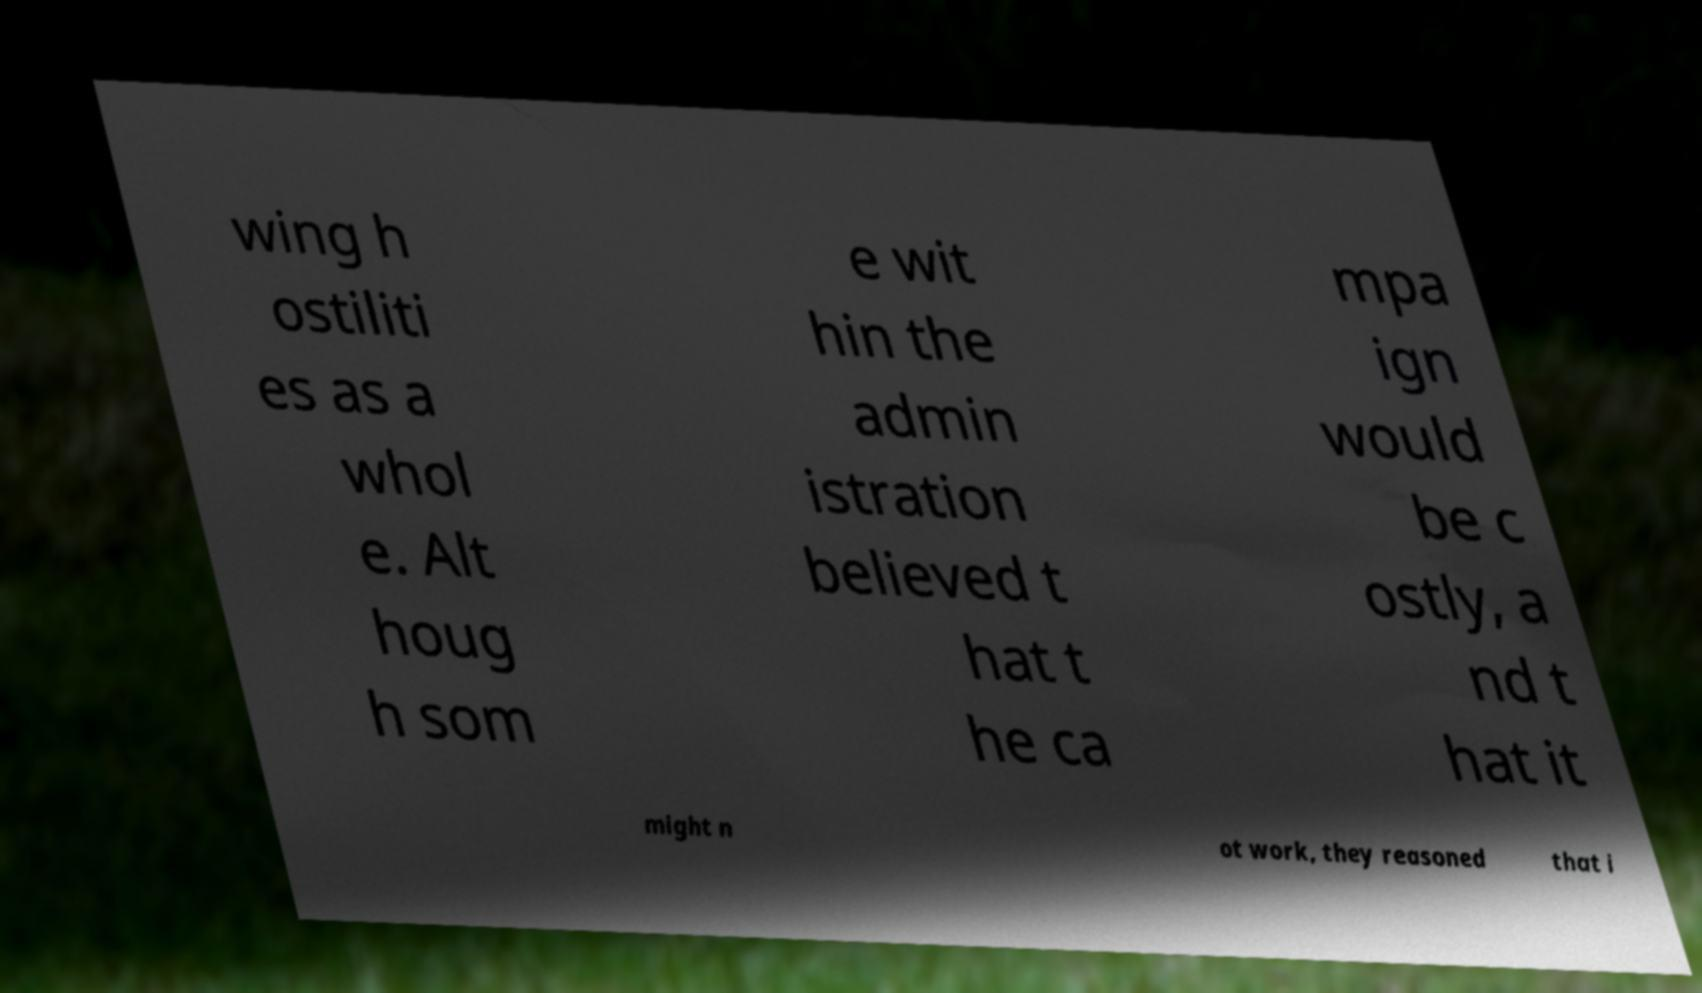Please read and relay the text visible in this image. What does it say? wing h ostiliti es as a whol e. Alt houg h som e wit hin the admin istration believed t hat t he ca mpa ign would be c ostly, a nd t hat it might n ot work, they reasoned that i 